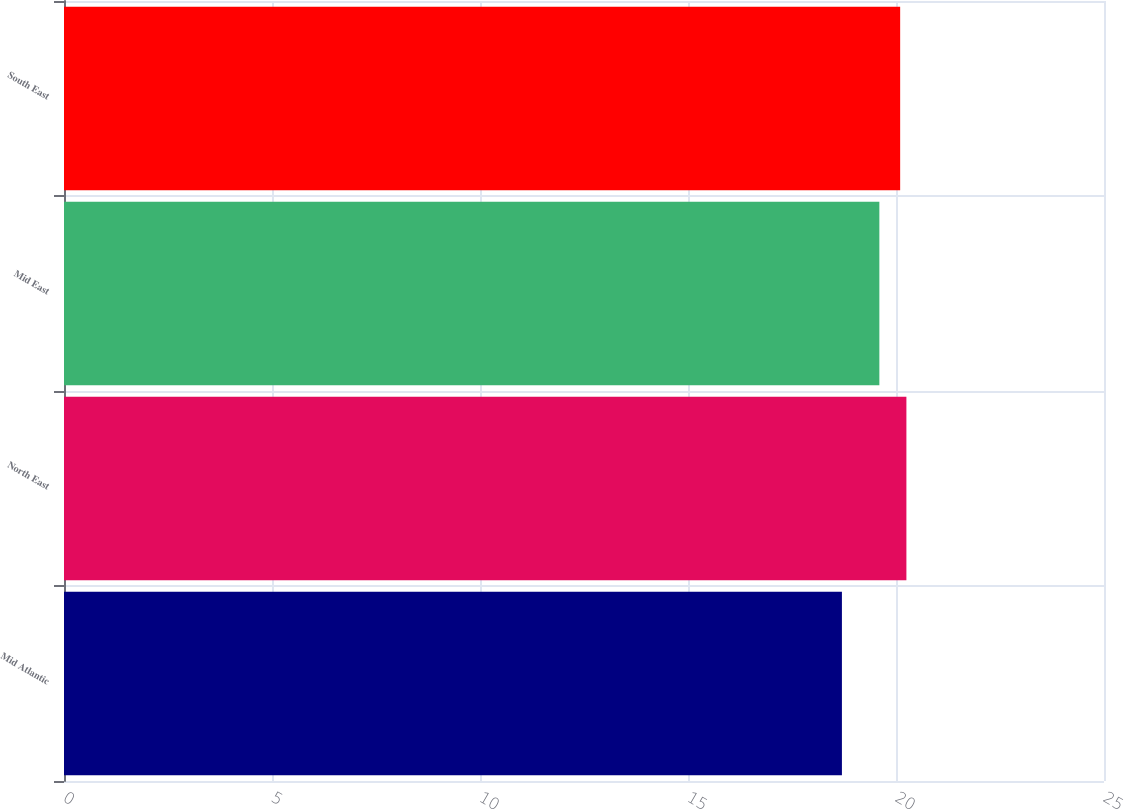Convert chart to OTSL. <chart><loc_0><loc_0><loc_500><loc_500><bar_chart><fcel>Mid Atlantic<fcel>North East<fcel>Mid East<fcel>South East<nl><fcel>18.7<fcel>20.25<fcel>19.6<fcel>20.1<nl></chart> 